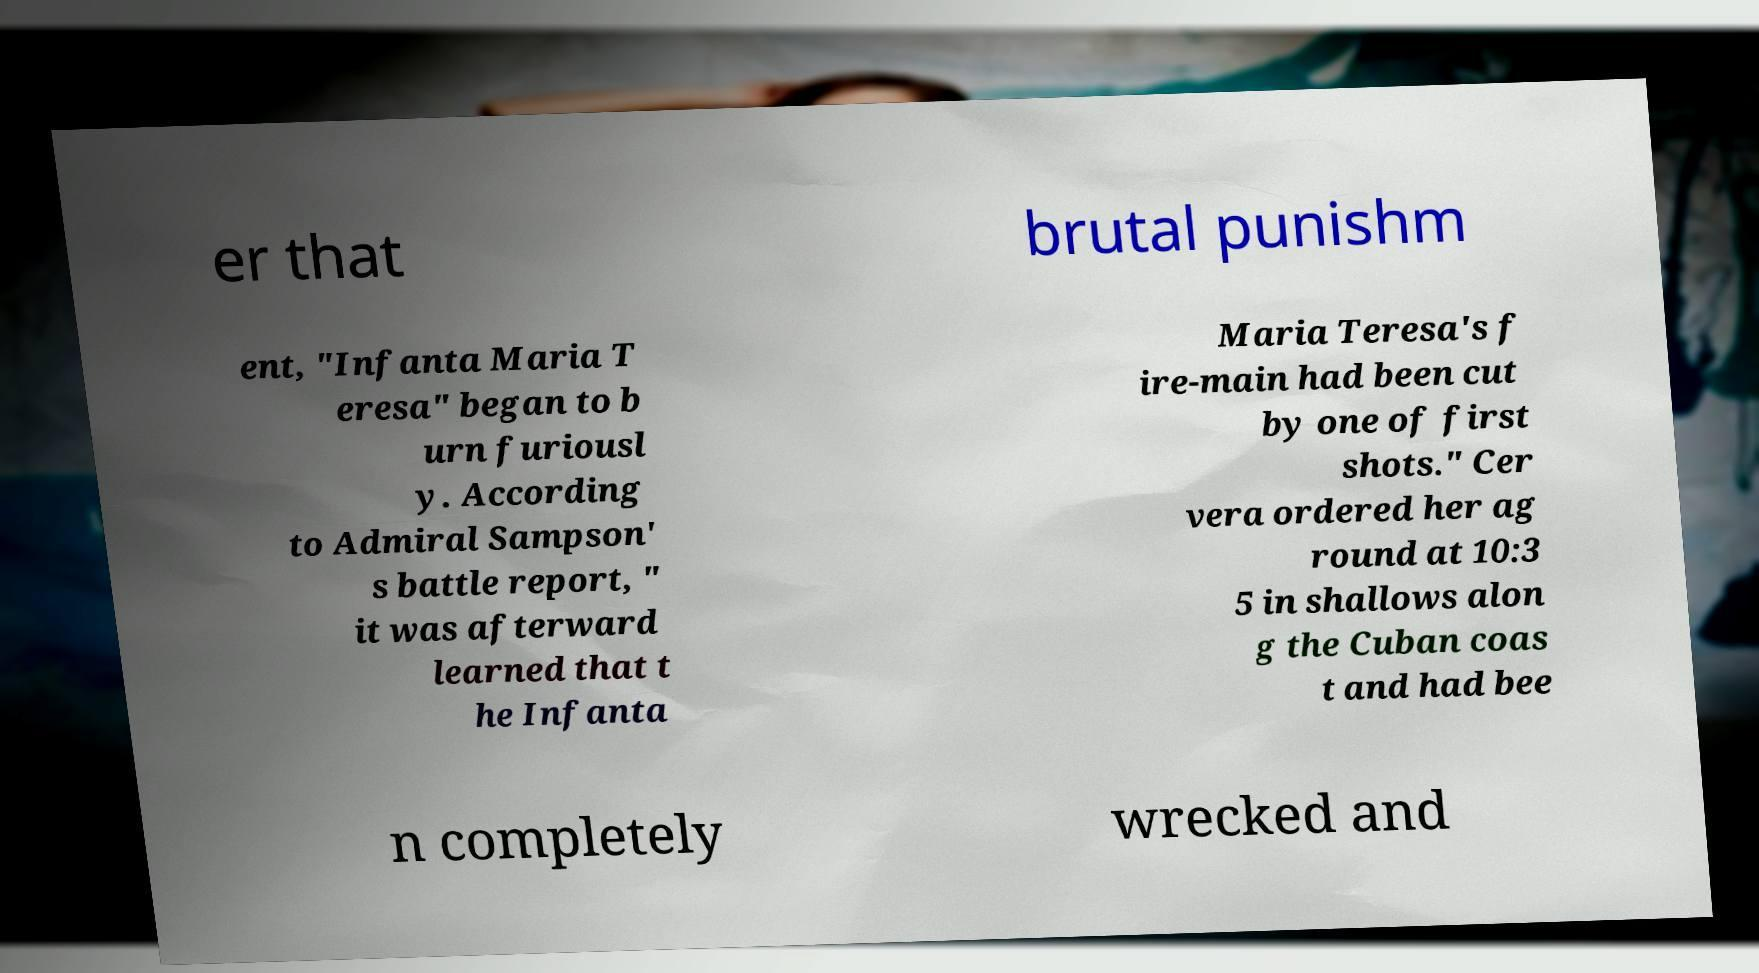Can you read and provide the text displayed in the image?This photo seems to have some interesting text. Can you extract and type it out for me? er that brutal punishm ent, "Infanta Maria T eresa" began to b urn furiousl y. According to Admiral Sampson' s battle report, " it was afterward learned that t he Infanta Maria Teresa's f ire-main had been cut by one of first shots." Cer vera ordered her ag round at 10:3 5 in shallows alon g the Cuban coas t and had bee n completely wrecked and 